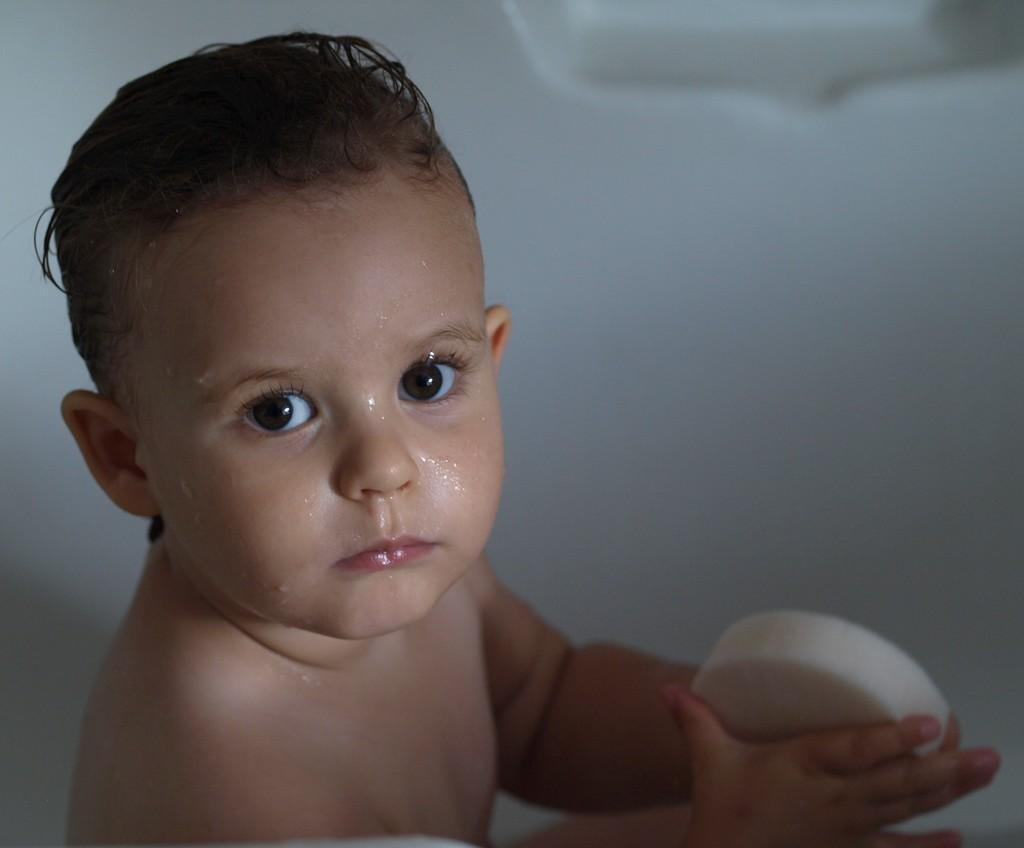Who is present in the image? There is a boy in the image. What is the boy doing in the image? The boy is sitting in a bathtub. What object is the boy holding in the image? The boy is holding a soap. Reasoning: Let's think step by step by step in order to produce the conversation. We start by identifying the main subject in the image, which is the boy. Then, we describe the boy's actions and the object he is holding, which are known from the provided facts. Each question is designed to elicit a specific detail about the image that is known from the given facts. Absurd Question/Answer: What type of drum is the boy playing in the image? There is no drum present in the image; the boy is sitting in a bathtub and holding a soap. How many carts can be seen in the image? There are no carts present in the image; the boy is sitting in a bathtub and holding a soap. 